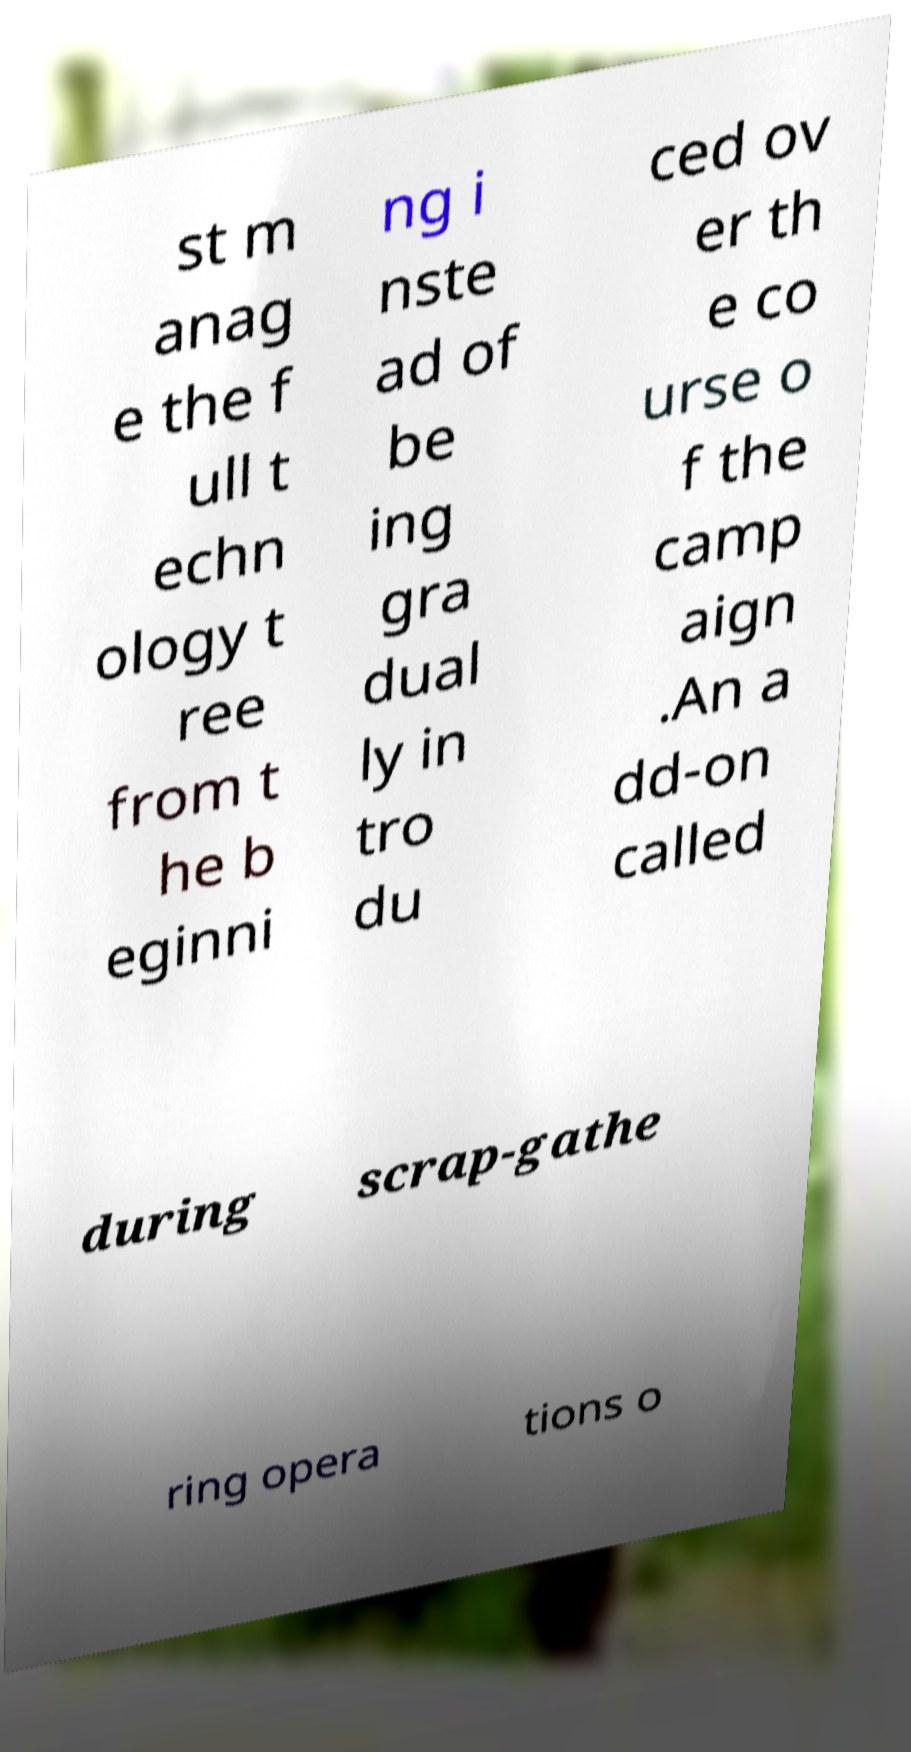For documentation purposes, I need the text within this image transcribed. Could you provide that? st m anag e the f ull t echn ology t ree from t he b eginni ng i nste ad of be ing gra dual ly in tro du ced ov er th e co urse o f the camp aign .An a dd-on called during scrap-gathe ring opera tions o 